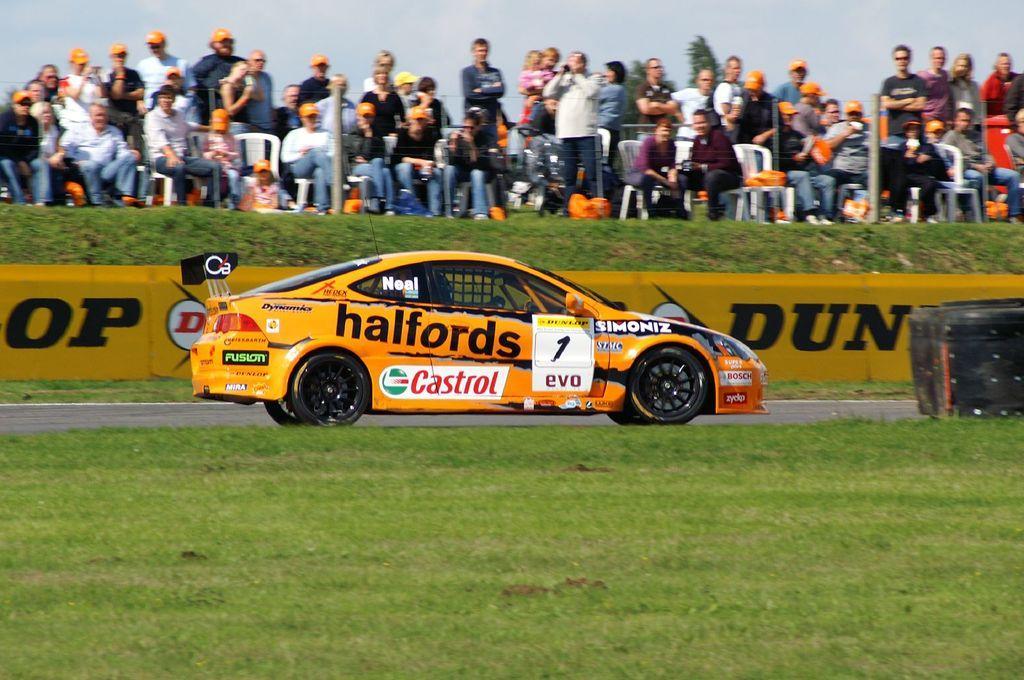Can you describe this image briefly? In this picture there is a car on the road. It is facing towards the right. It is in yellow in color with some text. At the bottom, there is grass. On the top there are people watching the car. Some of them are sitting on the chairs and some of them are standing. In the background there is a sky and a tree. 